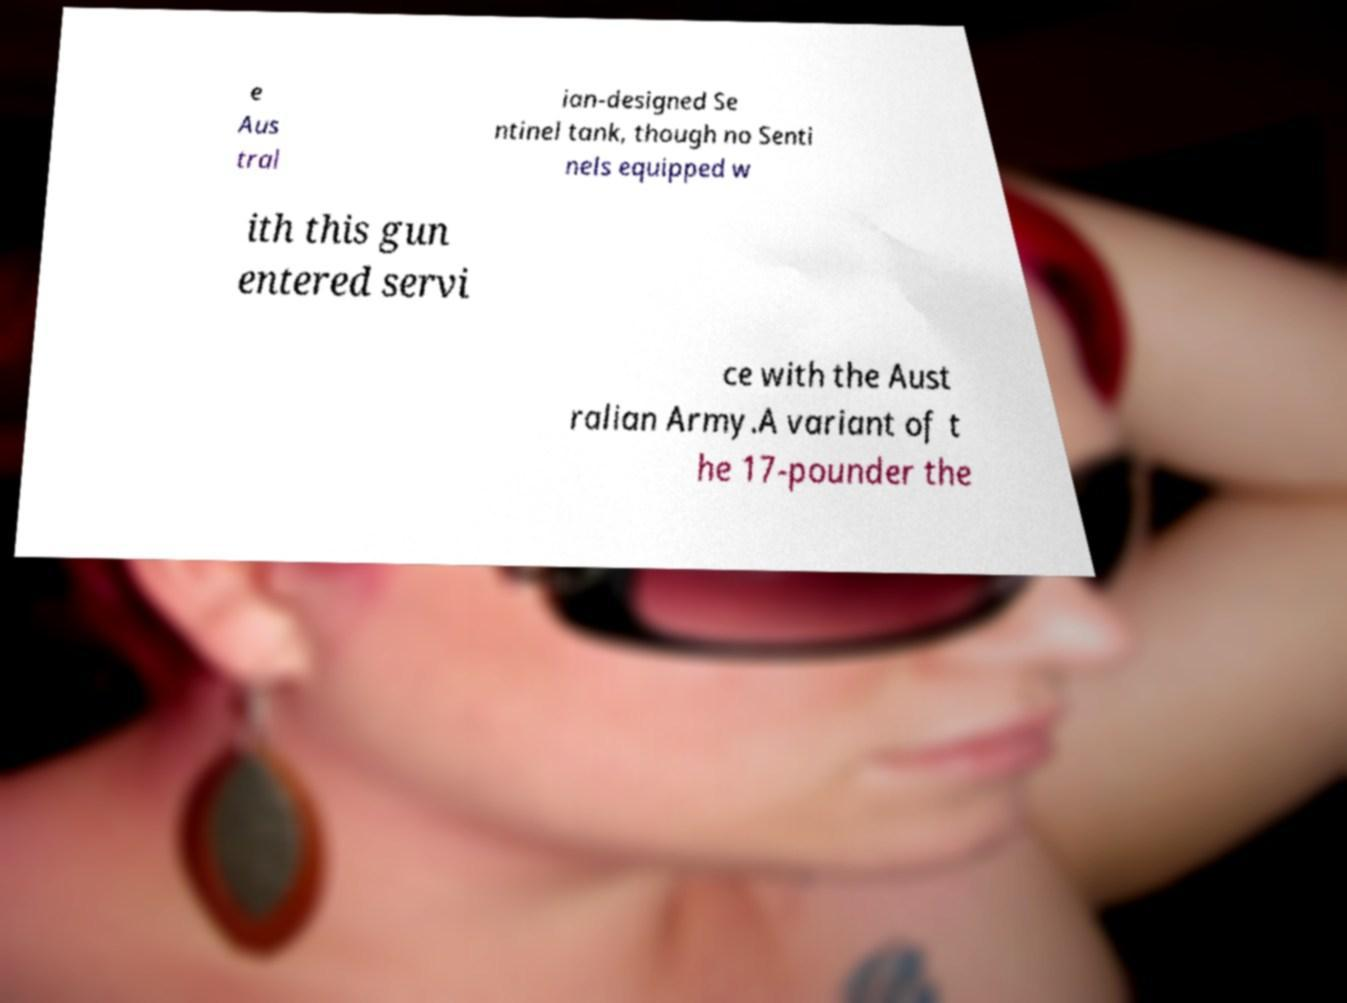I need the written content from this picture converted into text. Can you do that? e Aus tral ian-designed Se ntinel tank, though no Senti nels equipped w ith this gun entered servi ce with the Aust ralian Army.A variant of t he 17-pounder the 